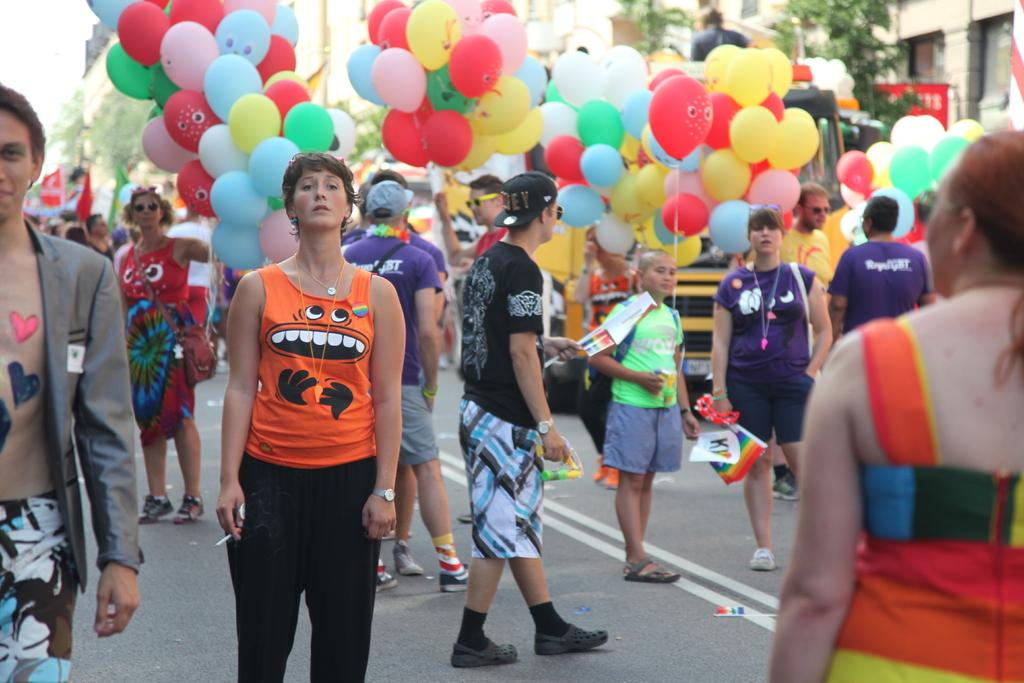What can be observed about the people in the image? There are people standing in the image. What are some of the people holding in the image? Some people are holding balloons in the image. What type of answer can be seen on the moon in the image? There is no moon present in the image, and therefore no answer can be seen on it. 